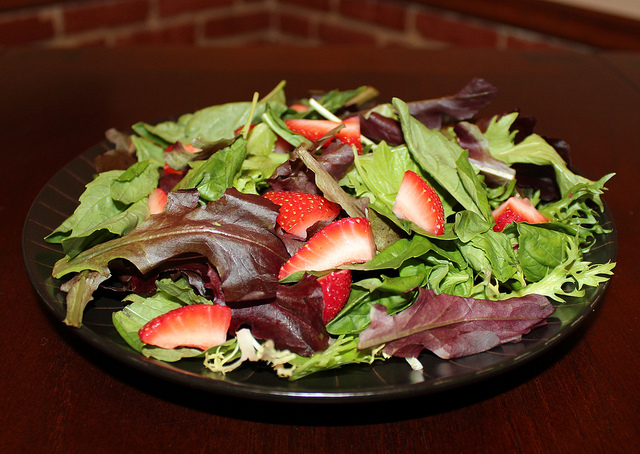Is this type of salad suitable for any specific diet or nutritional plan? Yes, this type of salad is generally low in calories yet rich in nutrients, making it suitable for several dietary plans including vegetarian, vegan, and low-calorie diets focused on fresh, wholesome ingredients. 